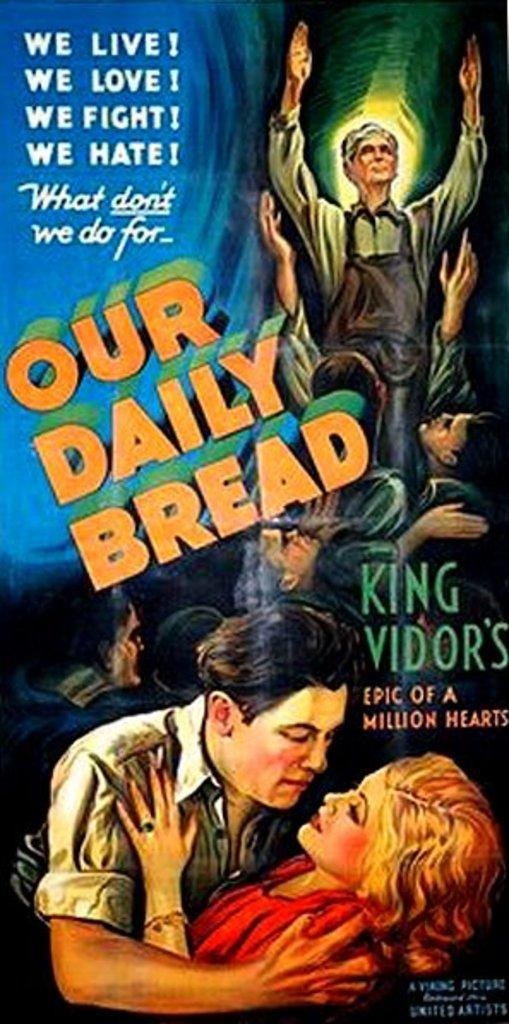<image>
Share a concise interpretation of the image provided. Poster which shows a man and a woman hugging with the words "We Live!" on top. 